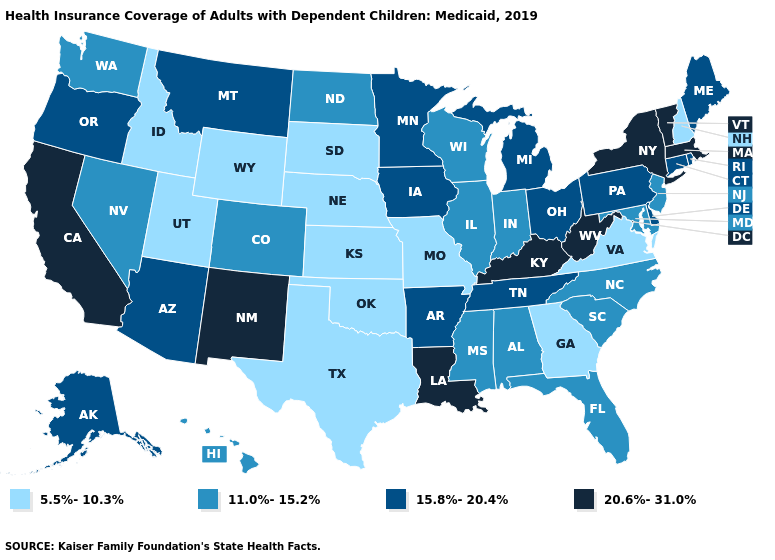Among the states that border Nevada , does Oregon have the lowest value?
Be succinct. No. Among the states that border Delaware , which have the lowest value?
Be succinct. Maryland, New Jersey. Which states have the lowest value in the USA?
Short answer required. Georgia, Idaho, Kansas, Missouri, Nebraska, New Hampshire, Oklahoma, South Dakota, Texas, Utah, Virginia, Wyoming. Does New Jersey have the same value as North Dakota?
Write a very short answer. Yes. Name the states that have a value in the range 11.0%-15.2%?
Write a very short answer. Alabama, Colorado, Florida, Hawaii, Illinois, Indiana, Maryland, Mississippi, Nevada, New Jersey, North Carolina, North Dakota, South Carolina, Washington, Wisconsin. Which states have the lowest value in the USA?
Concise answer only. Georgia, Idaho, Kansas, Missouri, Nebraska, New Hampshire, Oklahoma, South Dakota, Texas, Utah, Virginia, Wyoming. Name the states that have a value in the range 20.6%-31.0%?
Give a very brief answer. California, Kentucky, Louisiana, Massachusetts, New Mexico, New York, Vermont, West Virginia. Name the states that have a value in the range 20.6%-31.0%?
Answer briefly. California, Kentucky, Louisiana, Massachusetts, New Mexico, New York, Vermont, West Virginia. What is the value of Michigan?
Concise answer only. 15.8%-20.4%. What is the lowest value in the MidWest?
Concise answer only. 5.5%-10.3%. What is the value of Tennessee?
Short answer required. 15.8%-20.4%. Does the first symbol in the legend represent the smallest category?
Write a very short answer. Yes. How many symbols are there in the legend?
Write a very short answer. 4. Which states have the lowest value in the South?
Short answer required. Georgia, Oklahoma, Texas, Virginia. What is the highest value in states that border Oklahoma?
Give a very brief answer. 20.6%-31.0%. 